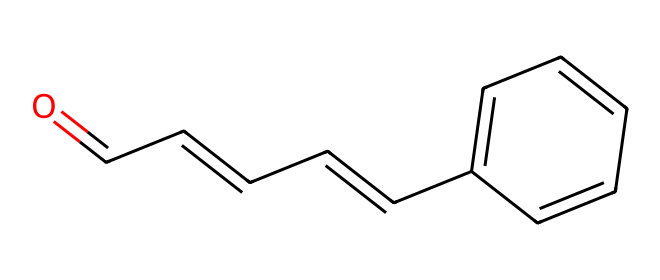What is the main functional group present in cinnamaldehyde? The chemical structure shows a carbonyl group (C=O) at the end of a carbon chain, characterizing it as an aldehyde.
Answer: carbonyl How many carbon atoms are there in cinnamaldehyde? By counting the carbon atoms in the structure, there are a total of 9 carbon atoms present.
Answer: 9 What is the role of the double bond in the structure of cinnamaldehyde? The double bond between carbon atoms indicates unsaturation, affecting the chemical reactivity and contributes to the aromatic characteristics of its scent.
Answer: unsaturation Which type of compound is cinnamaldehyde classified as? Cinnamaldehyde has an aldehyde functional group indicating it is classified as an aldehyde compound.
Answer: aldehyde How many hydrogen atoms are bonded to the carbon chain in cinnamaldehyde? The formula can be deduced to find that there are 8 hydrogen atoms, as each carbon typically bonds with enough hydrogen to have four bonds total, minus those involved in double bonds.
Answer: 8 What property of cinnamaldehyde is primarily responsible for its aroma? The chemical structure, specifically the presence of the aromatic ring, contributes significantly to the characteristic scent that is often associated with popcorn.
Answer: aromatic 